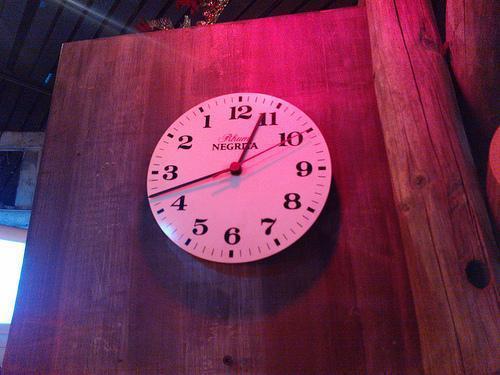How many clocks are visible?
Give a very brief answer. 1. How many hours are represented on the clock?
Give a very brief answer. 12. 